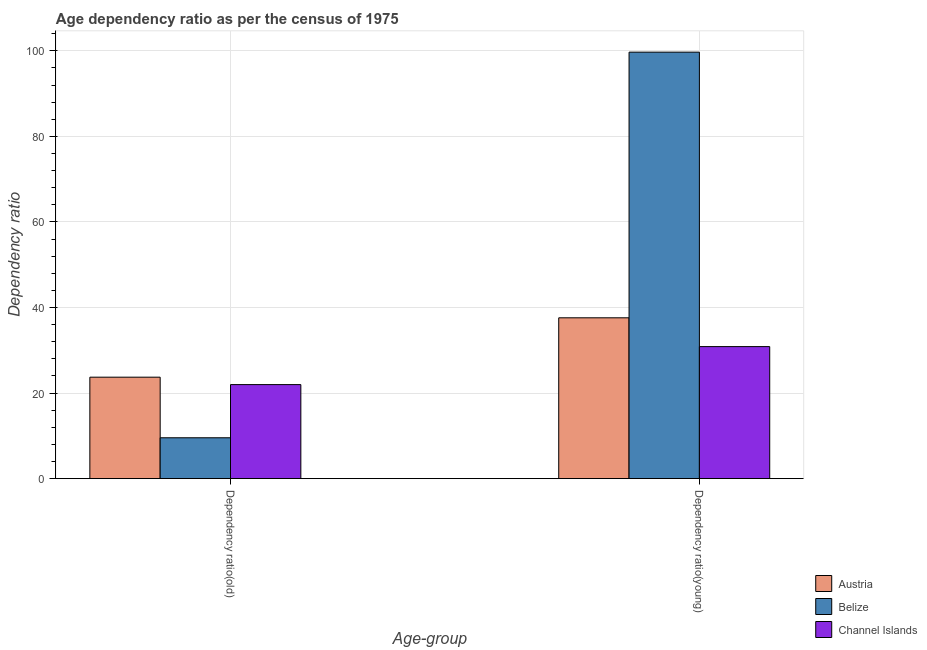How many bars are there on the 2nd tick from the left?
Provide a short and direct response. 3. How many bars are there on the 2nd tick from the right?
Your answer should be compact. 3. What is the label of the 1st group of bars from the left?
Provide a succinct answer. Dependency ratio(old). What is the age dependency ratio(old) in Belize?
Provide a succinct answer. 9.55. Across all countries, what is the maximum age dependency ratio(young)?
Your answer should be very brief. 99.68. Across all countries, what is the minimum age dependency ratio(young)?
Offer a terse response. 30.86. In which country was the age dependency ratio(young) maximum?
Ensure brevity in your answer.  Belize. In which country was the age dependency ratio(young) minimum?
Your response must be concise. Channel Islands. What is the total age dependency ratio(old) in the graph?
Provide a succinct answer. 55.23. What is the difference between the age dependency ratio(young) in Channel Islands and that in Austria?
Keep it short and to the point. -6.73. What is the difference between the age dependency ratio(old) in Channel Islands and the age dependency ratio(young) in Austria?
Provide a short and direct response. -15.61. What is the average age dependency ratio(young) per country?
Provide a short and direct response. 56.04. What is the difference between the age dependency ratio(young) and age dependency ratio(old) in Belize?
Your answer should be very brief. 90.14. In how many countries, is the age dependency ratio(young) greater than 4 ?
Provide a short and direct response. 3. What is the ratio of the age dependency ratio(old) in Channel Islands to that in Austria?
Your answer should be compact. 0.93. Is the age dependency ratio(old) in Channel Islands less than that in Austria?
Make the answer very short. Yes. What does the 2nd bar from the left in Dependency ratio(young) represents?
Give a very brief answer. Belize. What does the 2nd bar from the right in Dependency ratio(old) represents?
Your answer should be very brief. Belize. How many bars are there?
Your answer should be compact. 6. How many countries are there in the graph?
Keep it short and to the point. 3. Are the values on the major ticks of Y-axis written in scientific E-notation?
Your answer should be compact. No. Does the graph contain any zero values?
Your response must be concise. No. Does the graph contain grids?
Ensure brevity in your answer.  Yes. Where does the legend appear in the graph?
Your answer should be very brief. Bottom right. How many legend labels are there?
Make the answer very short. 3. What is the title of the graph?
Offer a very short reply. Age dependency ratio as per the census of 1975. Does "Morocco" appear as one of the legend labels in the graph?
Provide a succinct answer. No. What is the label or title of the X-axis?
Provide a short and direct response. Age-group. What is the label or title of the Y-axis?
Give a very brief answer. Dependency ratio. What is the Dependency ratio of Austria in Dependency ratio(old)?
Ensure brevity in your answer.  23.71. What is the Dependency ratio of Belize in Dependency ratio(old)?
Provide a short and direct response. 9.55. What is the Dependency ratio in Channel Islands in Dependency ratio(old)?
Ensure brevity in your answer.  21.98. What is the Dependency ratio in Austria in Dependency ratio(young)?
Your answer should be compact. 37.59. What is the Dependency ratio of Belize in Dependency ratio(young)?
Provide a short and direct response. 99.68. What is the Dependency ratio in Channel Islands in Dependency ratio(young)?
Offer a terse response. 30.86. Across all Age-group, what is the maximum Dependency ratio in Austria?
Offer a very short reply. 37.59. Across all Age-group, what is the maximum Dependency ratio of Belize?
Provide a succinct answer. 99.68. Across all Age-group, what is the maximum Dependency ratio in Channel Islands?
Your response must be concise. 30.86. Across all Age-group, what is the minimum Dependency ratio in Austria?
Keep it short and to the point. 23.71. Across all Age-group, what is the minimum Dependency ratio in Belize?
Ensure brevity in your answer.  9.55. Across all Age-group, what is the minimum Dependency ratio in Channel Islands?
Your answer should be very brief. 21.98. What is the total Dependency ratio in Austria in the graph?
Give a very brief answer. 61.3. What is the total Dependency ratio in Belize in the graph?
Your response must be concise. 109.23. What is the total Dependency ratio in Channel Islands in the graph?
Ensure brevity in your answer.  52.83. What is the difference between the Dependency ratio of Austria in Dependency ratio(old) and that in Dependency ratio(young)?
Give a very brief answer. -13.88. What is the difference between the Dependency ratio of Belize in Dependency ratio(old) and that in Dependency ratio(young)?
Make the answer very short. -90.14. What is the difference between the Dependency ratio of Channel Islands in Dependency ratio(old) and that in Dependency ratio(young)?
Give a very brief answer. -8.88. What is the difference between the Dependency ratio of Austria in Dependency ratio(old) and the Dependency ratio of Belize in Dependency ratio(young)?
Ensure brevity in your answer.  -75.97. What is the difference between the Dependency ratio of Austria in Dependency ratio(old) and the Dependency ratio of Channel Islands in Dependency ratio(young)?
Give a very brief answer. -7.15. What is the difference between the Dependency ratio in Belize in Dependency ratio(old) and the Dependency ratio in Channel Islands in Dependency ratio(young)?
Your answer should be very brief. -21.31. What is the average Dependency ratio in Austria per Age-group?
Provide a succinct answer. 30.65. What is the average Dependency ratio of Belize per Age-group?
Give a very brief answer. 54.62. What is the average Dependency ratio in Channel Islands per Age-group?
Keep it short and to the point. 26.42. What is the difference between the Dependency ratio of Austria and Dependency ratio of Belize in Dependency ratio(old)?
Keep it short and to the point. 14.16. What is the difference between the Dependency ratio of Austria and Dependency ratio of Channel Islands in Dependency ratio(old)?
Offer a terse response. 1.73. What is the difference between the Dependency ratio of Belize and Dependency ratio of Channel Islands in Dependency ratio(old)?
Give a very brief answer. -12.43. What is the difference between the Dependency ratio of Austria and Dependency ratio of Belize in Dependency ratio(young)?
Offer a terse response. -62.1. What is the difference between the Dependency ratio in Austria and Dependency ratio in Channel Islands in Dependency ratio(young)?
Ensure brevity in your answer.  6.73. What is the difference between the Dependency ratio in Belize and Dependency ratio in Channel Islands in Dependency ratio(young)?
Ensure brevity in your answer.  68.83. What is the ratio of the Dependency ratio in Austria in Dependency ratio(old) to that in Dependency ratio(young)?
Provide a succinct answer. 0.63. What is the ratio of the Dependency ratio in Belize in Dependency ratio(old) to that in Dependency ratio(young)?
Ensure brevity in your answer.  0.1. What is the ratio of the Dependency ratio in Channel Islands in Dependency ratio(old) to that in Dependency ratio(young)?
Offer a terse response. 0.71. What is the difference between the highest and the second highest Dependency ratio of Austria?
Offer a very short reply. 13.88. What is the difference between the highest and the second highest Dependency ratio in Belize?
Ensure brevity in your answer.  90.14. What is the difference between the highest and the second highest Dependency ratio in Channel Islands?
Provide a succinct answer. 8.88. What is the difference between the highest and the lowest Dependency ratio in Austria?
Provide a succinct answer. 13.88. What is the difference between the highest and the lowest Dependency ratio in Belize?
Your answer should be very brief. 90.14. What is the difference between the highest and the lowest Dependency ratio in Channel Islands?
Keep it short and to the point. 8.88. 